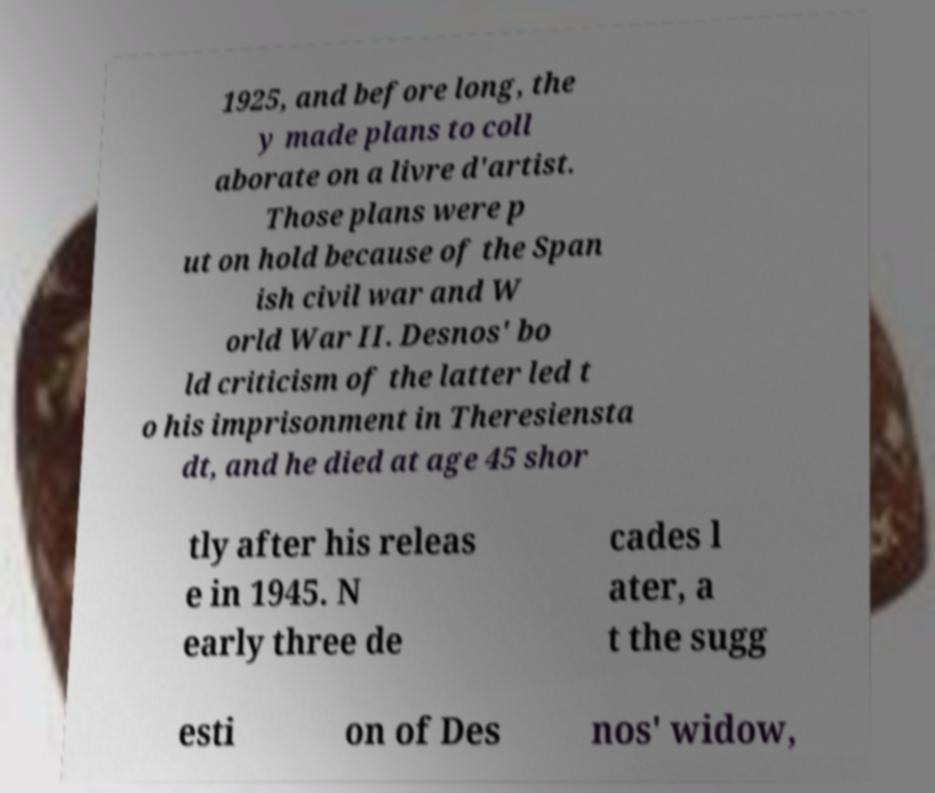Please read and relay the text visible in this image. What does it say? 1925, and before long, the y made plans to coll aborate on a livre d'artist. Those plans were p ut on hold because of the Span ish civil war and W orld War II. Desnos' bo ld criticism of the latter led t o his imprisonment in Theresiensta dt, and he died at age 45 shor tly after his releas e in 1945. N early three de cades l ater, a t the sugg esti on of Des nos' widow, 